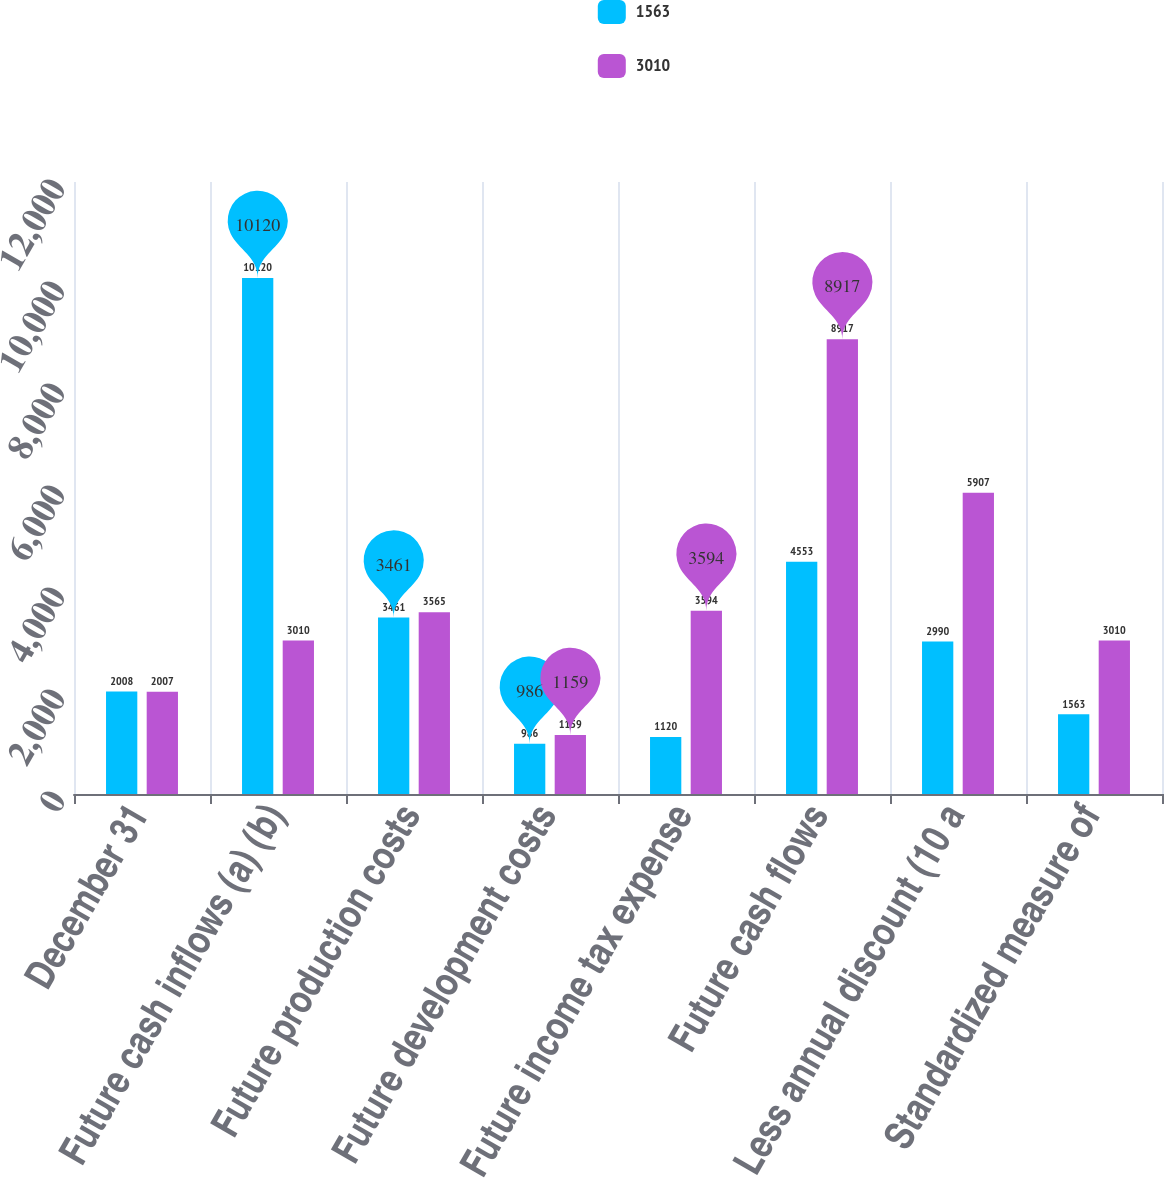<chart> <loc_0><loc_0><loc_500><loc_500><stacked_bar_chart><ecel><fcel>December 31<fcel>Future cash inflows (a) (b)<fcel>Future production costs<fcel>Future development costs<fcel>Future income tax expense<fcel>Future cash flows<fcel>Less annual discount (10 a<fcel>Standardized measure of<nl><fcel>1563<fcel>2008<fcel>10120<fcel>3461<fcel>986<fcel>1120<fcel>4553<fcel>2990<fcel>1563<nl><fcel>3010<fcel>2007<fcel>3010<fcel>3565<fcel>1159<fcel>3594<fcel>8917<fcel>5907<fcel>3010<nl></chart> 